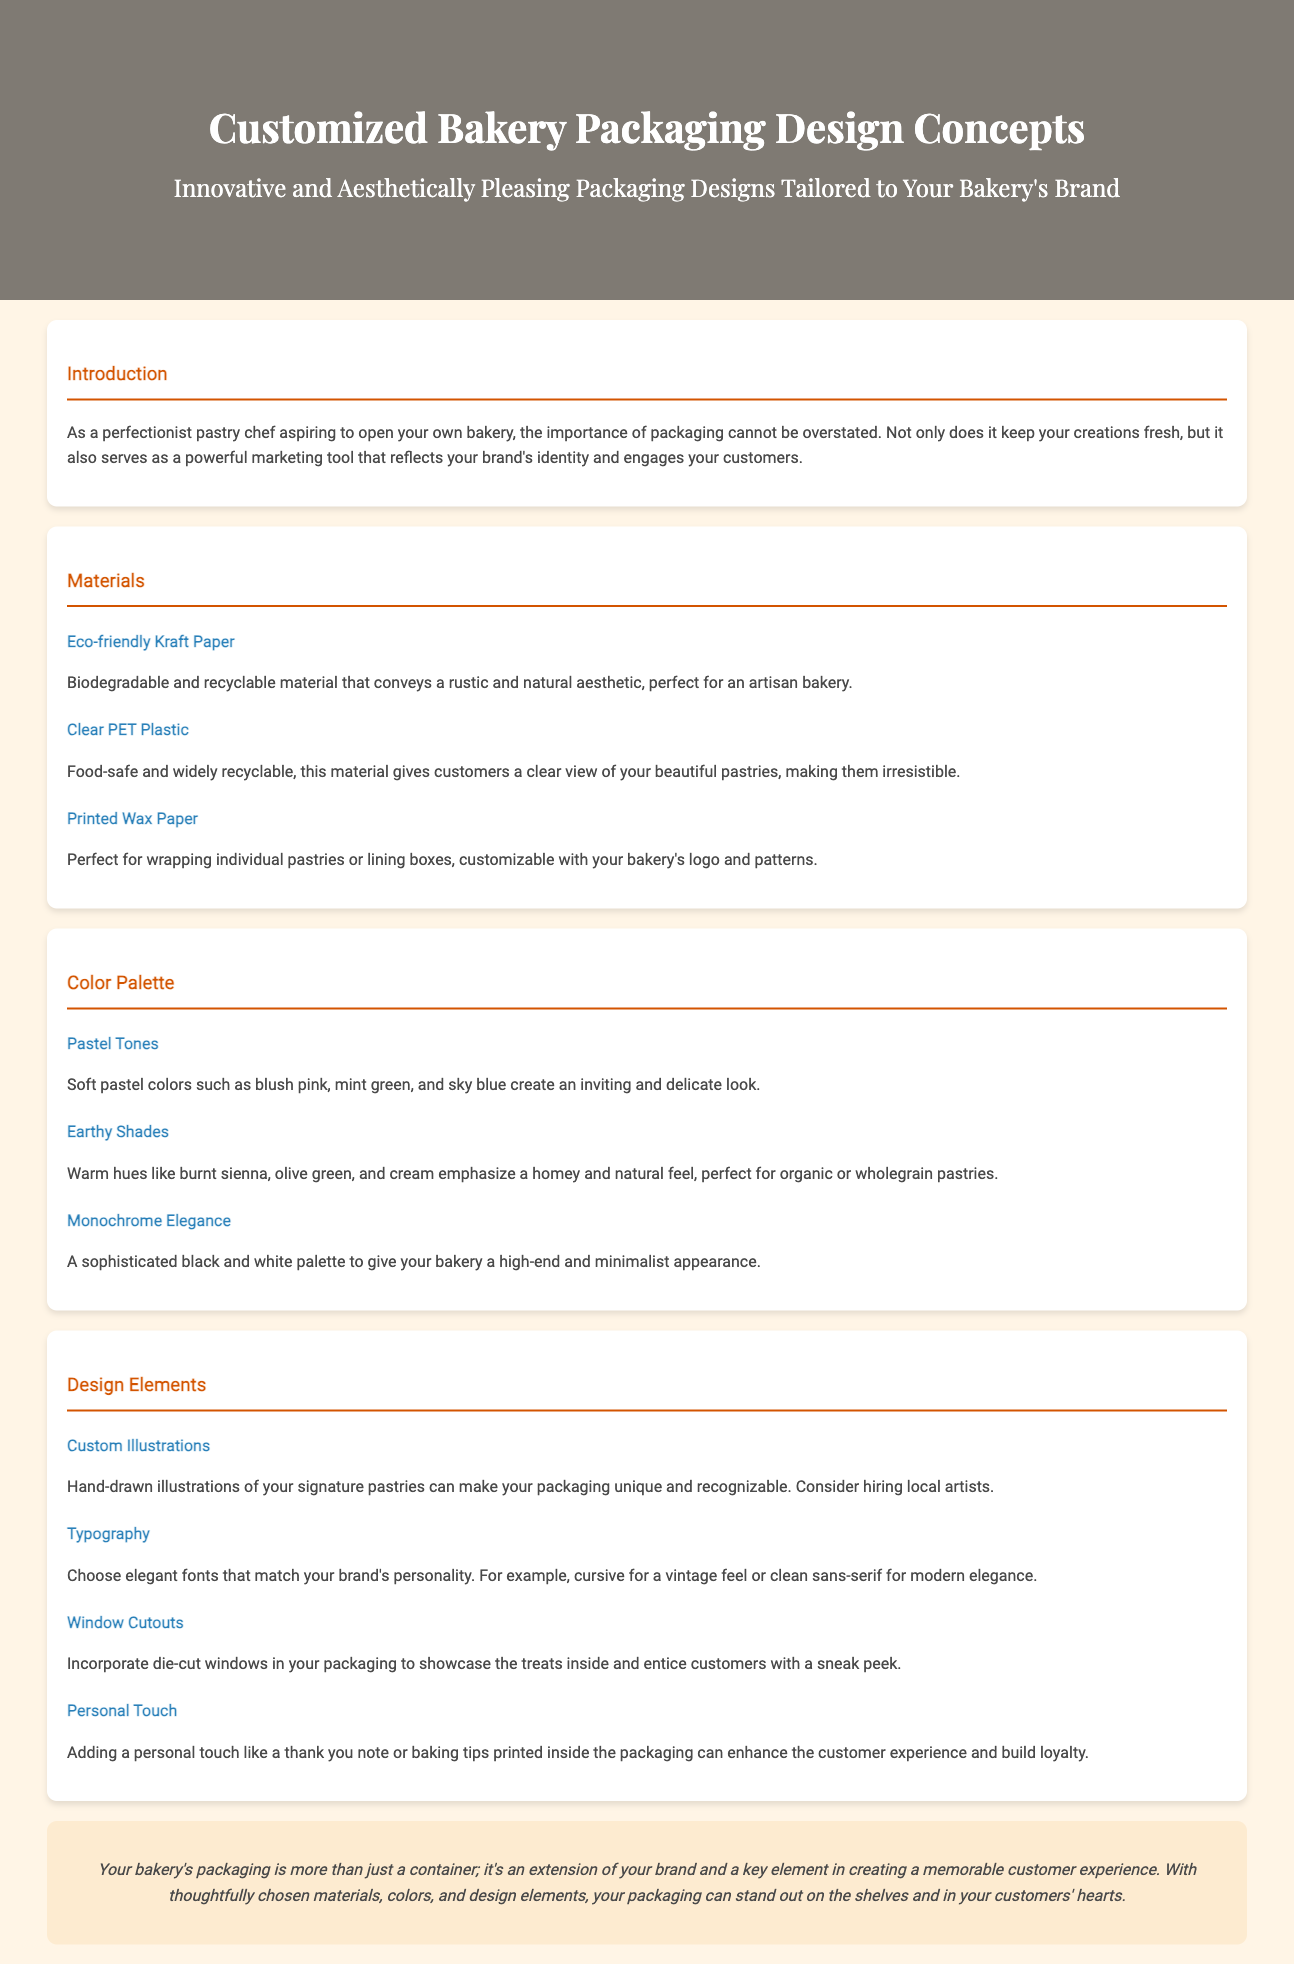What is the title of the document? The title is found in the header of the document, which clearly states "Customized Bakery Packaging Design Concepts."
Answer: Customized Bakery Packaging Design Concepts What material is described as biodegradable and recyclable? The document specifies "Eco-friendly Kraft Paper" as the biodegradable and recyclable material.
Answer: Eco-friendly Kraft Paper What color palette creates an inviting look? In the "Color Palette" section, "Pastel Tones" are mentioned as creating an inviting and delicate look.
Answer: Pastel Tones What design element can showcase the treats inside? "Window Cutouts" are mentioned as a design element that allows showcasing of the treats inside the packaging.
Answer: Window Cutouts What personal touch can enhance customer experience? The document suggests that adding a "thank you note or baking tips" can enhance the customer experience.
Answer: Thank you note or baking tips Which typography style is suggested for modern elegance? In the design elements section, "clean sans-serif" is mentioned for modern elegance in typography.
Answer: Clean sans-serif What is the overall conclusion about bakery packaging? The conclusion emphasizes that the bakery's packaging is an "extension of your brand" and important for the customer experience.
Answer: Extension of your brand Which material is recommended for a clear view of pastries? The document states "Clear PET Plastic" as a recommended material for a clear view of pastries.
Answer: Clear PET Plastic 